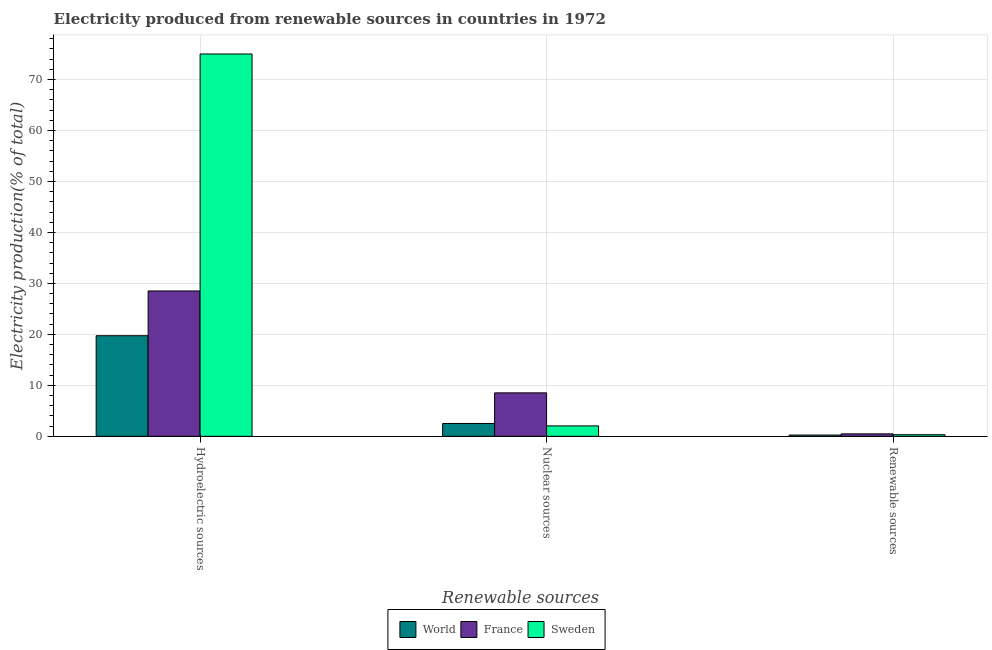How many different coloured bars are there?
Keep it short and to the point. 3. Are the number of bars per tick equal to the number of legend labels?
Your answer should be very brief. Yes. Are the number of bars on each tick of the X-axis equal?
Your answer should be very brief. Yes. What is the label of the 2nd group of bars from the left?
Provide a succinct answer. Nuclear sources. What is the percentage of electricity produced by nuclear sources in France?
Your answer should be compact. 8.52. Across all countries, what is the maximum percentage of electricity produced by renewable sources?
Make the answer very short. 0.48. Across all countries, what is the minimum percentage of electricity produced by hydroelectric sources?
Keep it short and to the point. 19.73. In which country was the percentage of electricity produced by nuclear sources maximum?
Provide a succinct answer. France. What is the total percentage of electricity produced by nuclear sources in the graph?
Offer a very short reply. 13.09. What is the difference between the percentage of electricity produced by renewable sources in World and that in France?
Offer a very short reply. -0.23. What is the difference between the percentage of electricity produced by renewable sources in Sweden and the percentage of electricity produced by nuclear sources in France?
Provide a short and direct response. -8.21. What is the average percentage of electricity produced by renewable sources per country?
Offer a very short reply. 0.35. What is the difference between the percentage of electricity produced by hydroelectric sources and percentage of electricity produced by nuclear sources in World?
Your answer should be compact. 17.21. What is the ratio of the percentage of electricity produced by hydroelectric sources in Sweden to that in World?
Provide a succinct answer. 3.8. What is the difference between the highest and the second highest percentage of electricity produced by nuclear sources?
Offer a very short reply. 6. What is the difference between the highest and the lowest percentage of electricity produced by renewable sources?
Provide a short and direct response. 0.23. In how many countries, is the percentage of electricity produced by nuclear sources greater than the average percentage of electricity produced by nuclear sources taken over all countries?
Your answer should be compact. 1. Are all the bars in the graph horizontal?
Ensure brevity in your answer.  No. What is the difference between two consecutive major ticks on the Y-axis?
Provide a short and direct response. 10. Are the values on the major ticks of Y-axis written in scientific E-notation?
Offer a very short reply. No. Does the graph contain grids?
Keep it short and to the point. Yes. Where does the legend appear in the graph?
Offer a terse response. Bottom center. How many legend labels are there?
Offer a terse response. 3. How are the legend labels stacked?
Provide a short and direct response. Horizontal. What is the title of the graph?
Keep it short and to the point. Electricity produced from renewable sources in countries in 1972. What is the label or title of the X-axis?
Keep it short and to the point. Renewable sources. What is the label or title of the Y-axis?
Give a very brief answer. Electricity production(% of total). What is the Electricity production(% of total) of World in Hydroelectric sources?
Ensure brevity in your answer.  19.73. What is the Electricity production(% of total) of France in Hydroelectric sources?
Make the answer very short. 28.52. What is the Electricity production(% of total) in Sweden in Hydroelectric sources?
Your answer should be very brief. 75. What is the Electricity production(% of total) in World in Nuclear sources?
Your response must be concise. 2.52. What is the Electricity production(% of total) of France in Nuclear sources?
Provide a succinct answer. 8.52. What is the Electricity production(% of total) in Sweden in Nuclear sources?
Your response must be concise. 2.04. What is the Electricity production(% of total) in World in Renewable sources?
Make the answer very short. 0.25. What is the Electricity production(% of total) in France in Renewable sources?
Your answer should be very brief. 0.48. What is the Electricity production(% of total) in Sweden in Renewable sources?
Make the answer very short. 0.32. Across all Renewable sources, what is the maximum Electricity production(% of total) of World?
Make the answer very short. 19.73. Across all Renewable sources, what is the maximum Electricity production(% of total) in France?
Offer a very short reply. 28.52. Across all Renewable sources, what is the maximum Electricity production(% of total) in Sweden?
Provide a short and direct response. 75. Across all Renewable sources, what is the minimum Electricity production(% of total) in World?
Offer a terse response. 0.25. Across all Renewable sources, what is the minimum Electricity production(% of total) of France?
Give a very brief answer. 0.48. Across all Renewable sources, what is the minimum Electricity production(% of total) in Sweden?
Make the answer very short. 0.32. What is the total Electricity production(% of total) in World in the graph?
Your response must be concise. 22.5. What is the total Electricity production(% of total) in France in the graph?
Provide a succinct answer. 37.52. What is the total Electricity production(% of total) of Sweden in the graph?
Your response must be concise. 77.36. What is the difference between the Electricity production(% of total) in World in Hydroelectric sources and that in Nuclear sources?
Make the answer very short. 17.21. What is the difference between the Electricity production(% of total) of France in Hydroelectric sources and that in Nuclear sources?
Provide a succinct answer. 19.99. What is the difference between the Electricity production(% of total) of Sweden in Hydroelectric sources and that in Nuclear sources?
Keep it short and to the point. 72.96. What is the difference between the Electricity production(% of total) in World in Hydroelectric sources and that in Renewable sources?
Your response must be concise. 19.49. What is the difference between the Electricity production(% of total) in France in Hydroelectric sources and that in Renewable sources?
Offer a terse response. 28.04. What is the difference between the Electricity production(% of total) of Sweden in Hydroelectric sources and that in Renewable sources?
Offer a very short reply. 74.69. What is the difference between the Electricity production(% of total) in World in Nuclear sources and that in Renewable sources?
Your answer should be compact. 2.27. What is the difference between the Electricity production(% of total) of France in Nuclear sources and that in Renewable sources?
Offer a very short reply. 8.04. What is the difference between the Electricity production(% of total) of Sweden in Nuclear sources and that in Renewable sources?
Offer a terse response. 1.73. What is the difference between the Electricity production(% of total) of World in Hydroelectric sources and the Electricity production(% of total) of France in Nuclear sources?
Your answer should be compact. 11.21. What is the difference between the Electricity production(% of total) in World in Hydroelectric sources and the Electricity production(% of total) in Sweden in Nuclear sources?
Offer a terse response. 17.69. What is the difference between the Electricity production(% of total) of France in Hydroelectric sources and the Electricity production(% of total) of Sweden in Nuclear sources?
Keep it short and to the point. 26.47. What is the difference between the Electricity production(% of total) in World in Hydroelectric sources and the Electricity production(% of total) in France in Renewable sources?
Your answer should be compact. 19.25. What is the difference between the Electricity production(% of total) in World in Hydroelectric sources and the Electricity production(% of total) in Sweden in Renewable sources?
Your answer should be compact. 19.42. What is the difference between the Electricity production(% of total) in France in Hydroelectric sources and the Electricity production(% of total) in Sweden in Renewable sources?
Provide a short and direct response. 28.2. What is the difference between the Electricity production(% of total) of World in Nuclear sources and the Electricity production(% of total) of France in Renewable sources?
Your answer should be very brief. 2.04. What is the difference between the Electricity production(% of total) in World in Nuclear sources and the Electricity production(% of total) in Sweden in Renewable sources?
Ensure brevity in your answer.  2.2. What is the difference between the Electricity production(% of total) of France in Nuclear sources and the Electricity production(% of total) of Sweden in Renewable sources?
Your answer should be compact. 8.21. What is the average Electricity production(% of total) of World per Renewable sources?
Keep it short and to the point. 7.5. What is the average Electricity production(% of total) of France per Renewable sources?
Offer a terse response. 12.51. What is the average Electricity production(% of total) of Sweden per Renewable sources?
Offer a terse response. 25.79. What is the difference between the Electricity production(% of total) in World and Electricity production(% of total) in France in Hydroelectric sources?
Keep it short and to the point. -8.78. What is the difference between the Electricity production(% of total) in World and Electricity production(% of total) in Sweden in Hydroelectric sources?
Your answer should be compact. -55.27. What is the difference between the Electricity production(% of total) of France and Electricity production(% of total) of Sweden in Hydroelectric sources?
Provide a short and direct response. -46.49. What is the difference between the Electricity production(% of total) of World and Electricity production(% of total) of France in Nuclear sources?
Make the answer very short. -6. What is the difference between the Electricity production(% of total) of World and Electricity production(% of total) of Sweden in Nuclear sources?
Your answer should be very brief. 0.47. What is the difference between the Electricity production(% of total) in France and Electricity production(% of total) in Sweden in Nuclear sources?
Your response must be concise. 6.48. What is the difference between the Electricity production(% of total) in World and Electricity production(% of total) in France in Renewable sources?
Give a very brief answer. -0.23. What is the difference between the Electricity production(% of total) in World and Electricity production(% of total) in Sweden in Renewable sources?
Keep it short and to the point. -0.07. What is the difference between the Electricity production(% of total) in France and Electricity production(% of total) in Sweden in Renewable sources?
Provide a short and direct response. 0.17. What is the ratio of the Electricity production(% of total) of World in Hydroelectric sources to that in Nuclear sources?
Ensure brevity in your answer.  7.83. What is the ratio of the Electricity production(% of total) of France in Hydroelectric sources to that in Nuclear sources?
Offer a very short reply. 3.35. What is the ratio of the Electricity production(% of total) in Sweden in Hydroelectric sources to that in Nuclear sources?
Provide a short and direct response. 36.68. What is the ratio of the Electricity production(% of total) of World in Hydroelectric sources to that in Renewable sources?
Make the answer very short. 79.84. What is the ratio of the Electricity production(% of total) in France in Hydroelectric sources to that in Renewable sources?
Give a very brief answer. 59.25. What is the ratio of the Electricity production(% of total) of Sweden in Hydroelectric sources to that in Renewable sources?
Provide a short and direct response. 237.8. What is the ratio of the Electricity production(% of total) in World in Nuclear sources to that in Renewable sources?
Make the answer very short. 10.19. What is the ratio of the Electricity production(% of total) in France in Nuclear sources to that in Renewable sources?
Keep it short and to the point. 17.71. What is the ratio of the Electricity production(% of total) of Sweden in Nuclear sources to that in Renewable sources?
Your answer should be very brief. 6.48. What is the difference between the highest and the second highest Electricity production(% of total) in World?
Make the answer very short. 17.21. What is the difference between the highest and the second highest Electricity production(% of total) of France?
Provide a short and direct response. 19.99. What is the difference between the highest and the second highest Electricity production(% of total) of Sweden?
Provide a succinct answer. 72.96. What is the difference between the highest and the lowest Electricity production(% of total) in World?
Provide a succinct answer. 19.49. What is the difference between the highest and the lowest Electricity production(% of total) in France?
Provide a succinct answer. 28.04. What is the difference between the highest and the lowest Electricity production(% of total) of Sweden?
Provide a succinct answer. 74.69. 